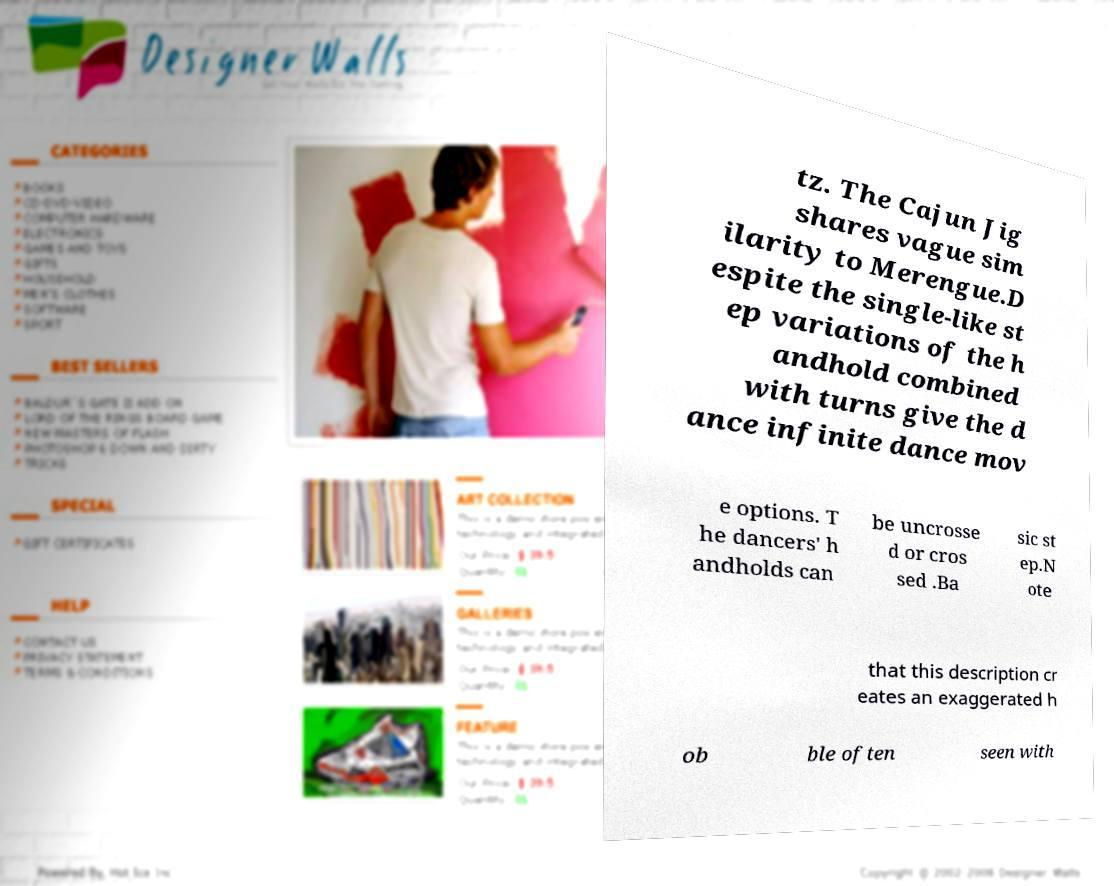What messages or text are displayed in this image? I need them in a readable, typed format. tz. The Cajun Jig shares vague sim ilarity to Merengue.D espite the single-like st ep variations of the h andhold combined with turns give the d ance infinite dance mov e options. T he dancers' h andholds can be uncrosse d or cros sed .Ba sic st ep.N ote that this description cr eates an exaggerated h ob ble often seen with 